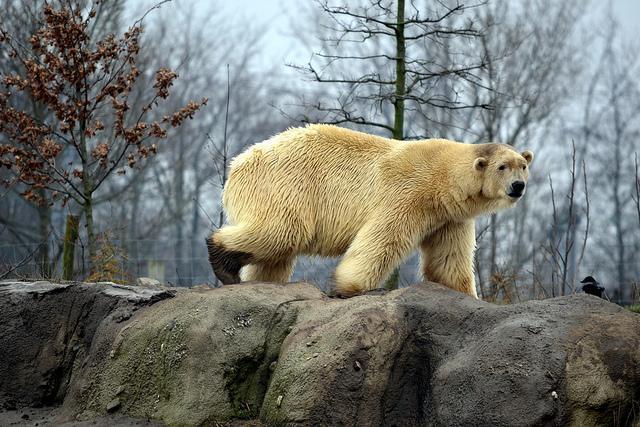How many of these people are alive?
Give a very brief answer. 0. 